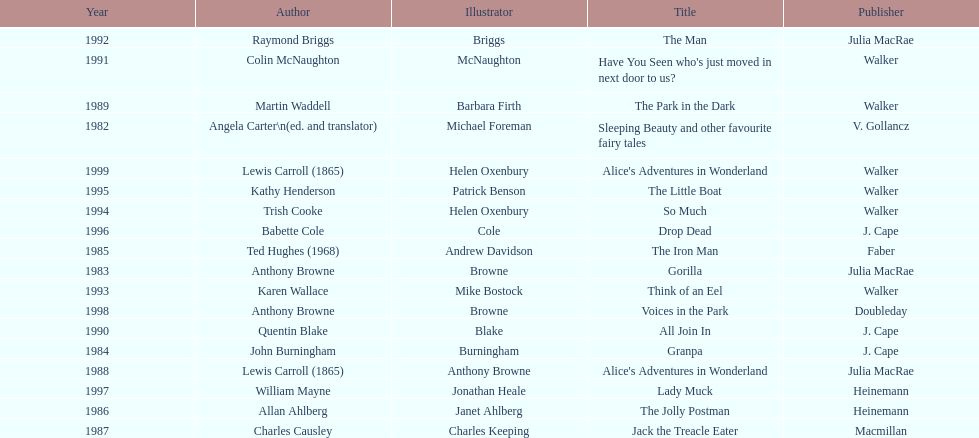Which author wrote the first award winner? Angela Carter. 